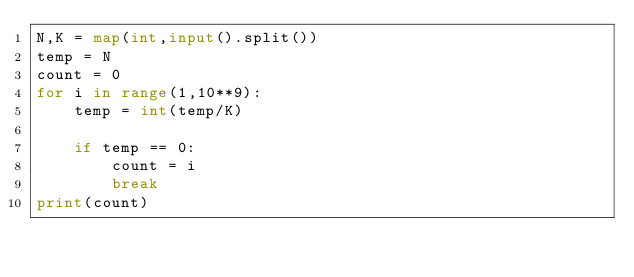<code> <loc_0><loc_0><loc_500><loc_500><_Python_>N,K = map(int,input().split())
temp = N
count = 0
for i in range(1,10**9):
    temp = int(temp/K)

    if temp == 0:
        count = i
        break
print(count)</code> 